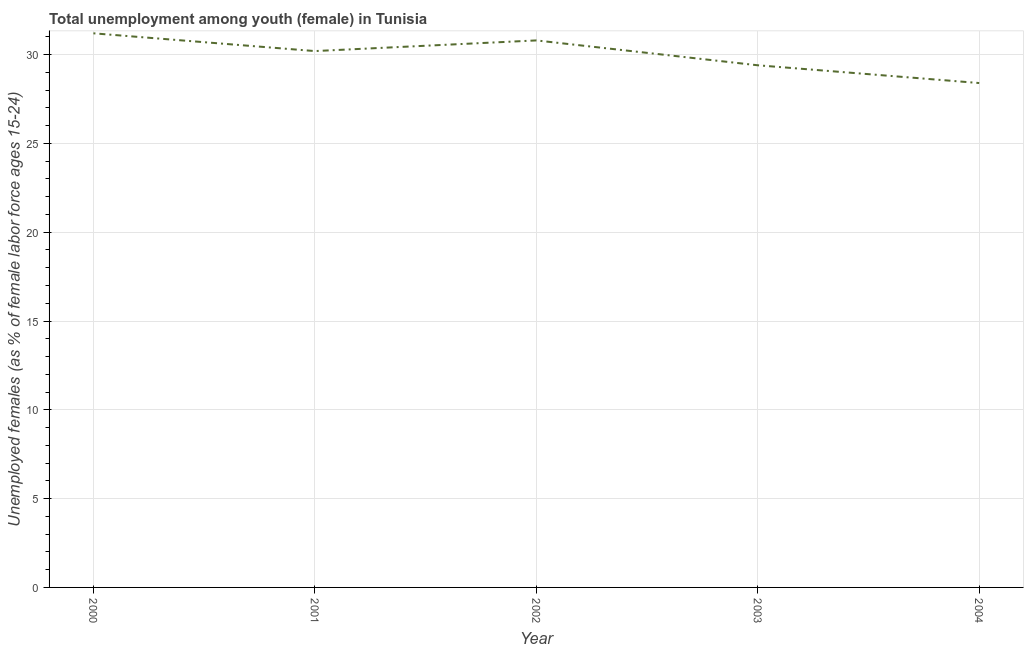What is the unemployed female youth population in 2001?
Your response must be concise. 30.2. Across all years, what is the maximum unemployed female youth population?
Provide a succinct answer. 31.2. Across all years, what is the minimum unemployed female youth population?
Ensure brevity in your answer.  28.4. What is the sum of the unemployed female youth population?
Make the answer very short. 150. What is the difference between the unemployed female youth population in 2002 and 2003?
Provide a succinct answer. 1.4. What is the average unemployed female youth population per year?
Offer a terse response. 30. What is the median unemployed female youth population?
Your answer should be very brief. 30.2. In how many years, is the unemployed female youth population greater than 4 %?
Your answer should be compact. 5. What is the ratio of the unemployed female youth population in 2002 to that in 2004?
Keep it short and to the point. 1.08. Is the unemployed female youth population in 2000 less than that in 2003?
Your response must be concise. No. What is the difference between the highest and the second highest unemployed female youth population?
Give a very brief answer. 0.4. Is the sum of the unemployed female youth population in 2000 and 2001 greater than the maximum unemployed female youth population across all years?
Give a very brief answer. Yes. What is the difference between the highest and the lowest unemployed female youth population?
Give a very brief answer. 2.8. Does the unemployed female youth population monotonically increase over the years?
Give a very brief answer. No. How many lines are there?
Provide a short and direct response. 1. How many years are there in the graph?
Your answer should be very brief. 5. What is the difference between two consecutive major ticks on the Y-axis?
Give a very brief answer. 5. Does the graph contain any zero values?
Your answer should be compact. No. Does the graph contain grids?
Your answer should be compact. Yes. What is the title of the graph?
Your answer should be very brief. Total unemployment among youth (female) in Tunisia. What is the label or title of the X-axis?
Provide a short and direct response. Year. What is the label or title of the Y-axis?
Your answer should be compact. Unemployed females (as % of female labor force ages 15-24). What is the Unemployed females (as % of female labor force ages 15-24) of 2000?
Make the answer very short. 31.2. What is the Unemployed females (as % of female labor force ages 15-24) of 2001?
Offer a very short reply. 30.2. What is the Unemployed females (as % of female labor force ages 15-24) in 2002?
Provide a short and direct response. 30.8. What is the Unemployed females (as % of female labor force ages 15-24) in 2003?
Provide a succinct answer. 29.4. What is the Unemployed females (as % of female labor force ages 15-24) in 2004?
Make the answer very short. 28.4. What is the difference between the Unemployed females (as % of female labor force ages 15-24) in 2000 and 2003?
Make the answer very short. 1.8. What is the difference between the Unemployed females (as % of female labor force ages 15-24) in 2000 and 2004?
Your answer should be compact. 2.8. What is the difference between the Unemployed females (as % of female labor force ages 15-24) in 2001 and 2002?
Ensure brevity in your answer.  -0.6. What is the difference between the Unemployed females (as % of female labor force ages 15-24) in 2001 and 2004?
Your response must be concise. 1.8. What is the difference between the Unemployed females (as % of female labor force ages 15-24) in 2002 and 2004?
Ensure brevity in your answer.  2.4. What is the difference between the Unemployed females (as % of female labor force ages 15-24) in 2003 and 2004?
Ensure brevity in your answer.  1. What is the ratio of the Unemployed females (as % of female labor force ages 15-24) in 2000 to that in 2001?
Ensure brevity in your answer.  1.03. What is the ratio of the Unemployed females (as % of female labor force ages 15-24) in 2000 to that in 2003?
Your answer should be very brief. 1.06. What is the ratio of the Unemployed females (as % of female labor force ages 15-24) in 2000 to that in 2004?
Your response must be concise. 1.1. What is the ratio of the Unemployed females (as % of female labor force ages 15-24) in 2001 to that in 2003?
Give a very brief answer. 1.03. What is the ratio of the Unemployed females (as % of female labor force ages 15-24) in 2001 to that in 2004?
Offer a very short reply. 1.06. What is the ratio of the Unemployed females (as % of female labor force ages 15-24) in 2002 to that in 2003?
Offer a very short reply. 1.05. What is the ratio of the Unemployed females (as % of female labor force ages 15-24) in 2002 to that in 2004?
Provide a short and direct response. 1.08. What is the ratio of the Unemployed females (as % of female labor force ages 15-24) in 2003 to that in 2004?
Give a very brief answer. 1.03. 